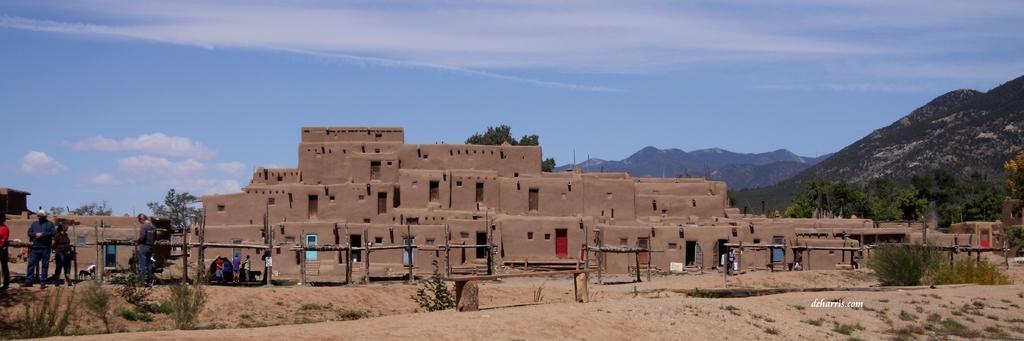In one or two sentences, can you explain what this image depicts? In this image I can see grass, plants, buildings, trees, mountains, clouds and the sky. I can also see few people in this image and here I can see watermark. 